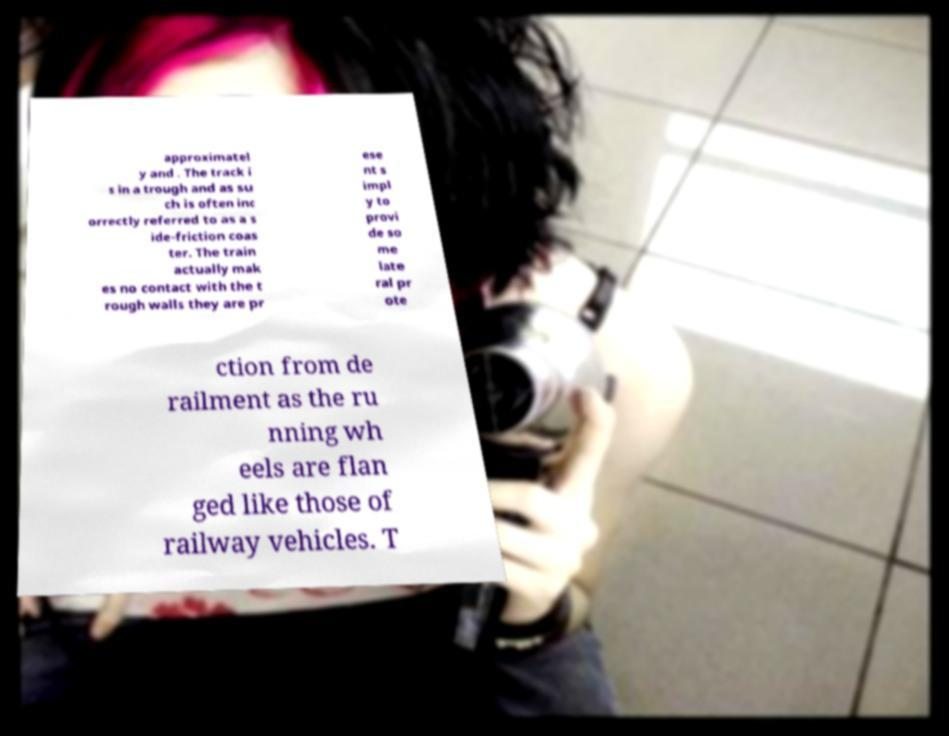Could you assist in decoding the text presented in this image and type it out clearly? approximatel y and . The track i s in a trough and as su ch is often inc orrectly referred to as a s ide-friction coas ter. The train actually mak es no contact with the t rough walls they are pr ese nt s impl y to provi de so me late ral pr ote ction from de railment as the ru nning wh eels are flan ged like those of railway vehicles. T 